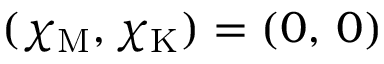Convert formula to latex. <formula><loc_0><loc_0><loc_500><loc_500>( \chi _ { M } , \chi _ { K } ) = ( 0 , \, 0 )</formula> 